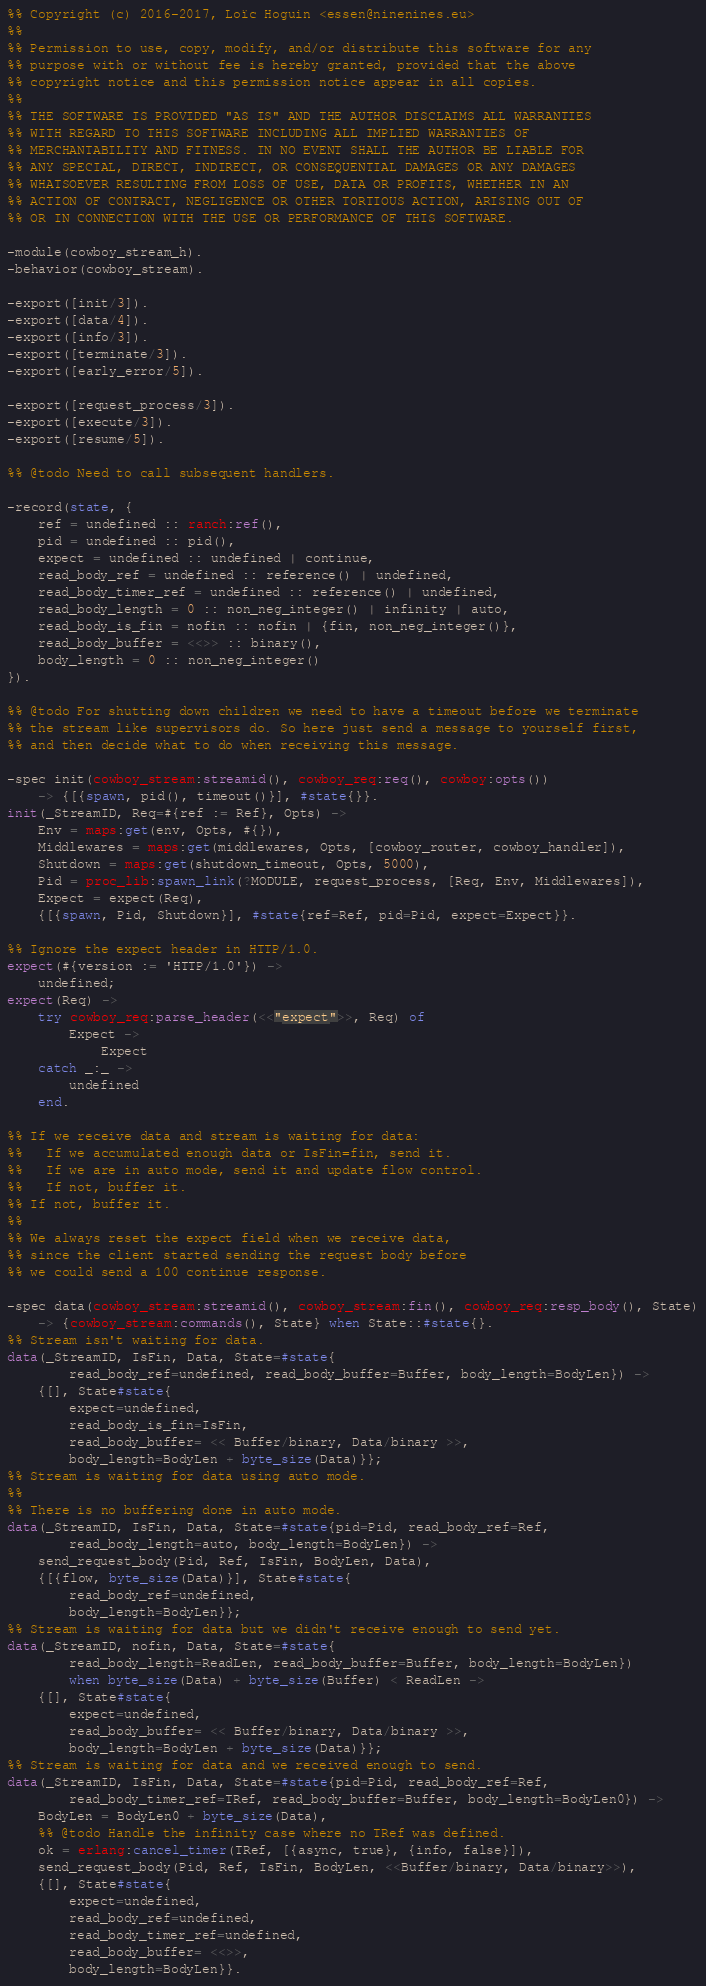<code> <loc_0><loc_0><loc_500><loc_500><_Erlang_>%% Copyright (c) 2016-2017, Loïc Hoguin <essen@ninenines.eu>
%%
%% Permission to use, copy, modify, and/or distribute this software for any
%% purpose with or without fee is hereby granted, provided that the above
%% copyright notice and this permission notice appear in all copies.
%%
%% THE SOFTWARE IS PROVIDED "AS IS" AND THE AUTHOR DISCLAIMS ALL WARRANTIES
%% WITH REGARD TO THIS SOFTWARE INCLUDING ALL IMPLIED WARRANTIES OF
%% MERCHANTABILITY AND FITNESS. IN NO EVENT SHALL THE AUTHOR BE LIABLE FOR
%% ANY SPECIAL, DIRECT, INDIRECT, OR CONSEQUENTIAL DAMAGES OR ANY DAMAGES
%% WHATSOEVER RESULTING FROM LOSS OF USE, DATA OR PROFITS, WHETHER IN AN
%% ACTION OF CONTRACT, NEGLIGENCE OR OTHER TORTIOUS ACTION, ARISING OUT OF
%% OR IN CONNECTION WITH THE USE OR PERFORMANCE OF THIS SOFTWARE.

-module(cowboy_stream_h).
-behavior(cowboy_stream).

-export([init/3]).
-export([data/4]).
-export([info/3]).
-export([terminate/3]).
-export([early_error/5]).

-export([request_process/3]).
-export([execute/3]).
-export([resume/5]).

%% @todo Need to call subsequent handlers.

-record(state, {
	ref = undefined :: ranch:ref(),
	pid = undefined :: pid(),
	expect = undefined :: undefined | continue,
	read_body_ref = undefined :: reference() | undefined,
	read_body_timer_ref = undefined :: reference() | undefined,
	read_body_length = 0 :: non_neg_integer() | infinity | auto,
	read_body_is_fin = nofin :: nofin | {fin, non_neg_integer()},
	read_body_buffer = <<>> :: binary(),
	body_length = 0 :: non_neg_integer()
}).

%% @todo For shutting down children we need to have a timeout before we terminate
%% the stream like supervisors do. So here just send a message to yourself first,
%% and then decide what to do when receiving this message.

-spec init(cowboy_stream:streamid(), cowboy_req:req(), cowboy:opts())
	-> {[{spawn, pid(), timeout()}], #state{}}.
init(_StreamID, Req=#{ref := Ref}, Opts) ->
	Env = maps:get(env, Opts, #{}),
	Middlewares = maps:get(middlewares, Opts, [cowboy_router, cowboy_handler]),
	Shutdown = maps:get(shutdown_timeout, Opts, 5000),
	Pid = proc_lib:spawn_link(?MODULE, request_process, [Req, Env, Middlewares]),
	Expect = expect(Req),
	{[{spawn, Pid, Shutdown}], #state{ref=Ref, pid=Pid, expect=Expect}}.

%% Ignore the expect header in HTTP/1.0.
expect(#{version := 'HTTP/1.0'}) ->
	undefined;
expect(Req) ->
	try cowboy_req:parse_header(<<"expect">>, Req) of
		Expect ->
			Expect
	catch _:_ ->
		undefined
	end.

%% If we receive data and stream is waiting for data:
%%   If we accumulated enough data or IsFin=fin, send it.
%%   If we are in auto mode, send it and update flow control.
%%   If not, buffer it.
%% If not, buffer it.
%%
%% We always reset the expect field when we receive data,
%% since the client started sending the request body before
%% we could send a 100 continue response.

-spec data(cowboy_stream:streamid(), cowboy_stream:fin(), cowboy_req:resp_body(), State)
	-> {cowboy_stream:commands(), State} when State::#state{}.
%% Stream isn't waiting for data.
data(_StreamID, IsFin, Data, State=#state{
		read_body_ref=undefined, read_body_buffer=Buffer, body_length=BodyLen}) ->
	{[], State#state{
		expect=undefined,
		read_body_is_fin=IsFin,
		read_body_buffer= << Buffer/binary, Data/binary >>,
		body_length=BodyLen + byte_size(Data)}};
%% Stream is waiting for data using auto mode.
%%
%% There is no buffering done in auto mode.
data(_StreamID, IsFin, Data, State=#state{pid=Pid, read_body_ref=Ref,
		read_body_length=auto, body_length=BodyLen}) ->
	send_request_body(Pid, Ref, IsFin, BodyLen, Data),
	{[{flow, byte_size(Data)}], State#state{
		read_body_ref=undefined,
		body_length=BodyLen}};
%% Stream is waiting for data but we didn't receive enough to send yet.
data(_StreamID, nofin, Data, State=#state{
		read_body_length=ReadLen, read_body_buffer=Buffer, body_length=BodyLen})
		when byte_size(Data) + byte_size(Buffer) < ReadLen ->
	{[], State#state{
		expect=undefined,
		read_body_buffer= << Buffer/binary, Data/binary >>,
		body_length=BodyLen + byte_size(Data)}};
%% Stream is waiting for data and we received enough to send.
data(_StreamID, IsFin, Data, State=#state{pid=Pid, read_body_ref=Ref,
		read_body_timer_ref=TRef, read_body_buffer=Buffer, body_length=BodyLen0}) ->
	BodyLen = BodyLen0 + byte_size(Data),
	%% @todo Handle the infinity case where no TRef was defined.
	ok = erlang:cancel_timer(TRef, [{async, true}, {info, false}]),
	send_request_body(Pid, Ref, IsFin, BodyLen, <<Buffer/binary, Data/binary>>),
	{[], State#state{
		expect=undefined,
		read_body_ref=undefined,
		read_body_timer_ref=undefined,
		read_body_buffer= <<>>,
		body_length=BodyLen}}.
</code> 